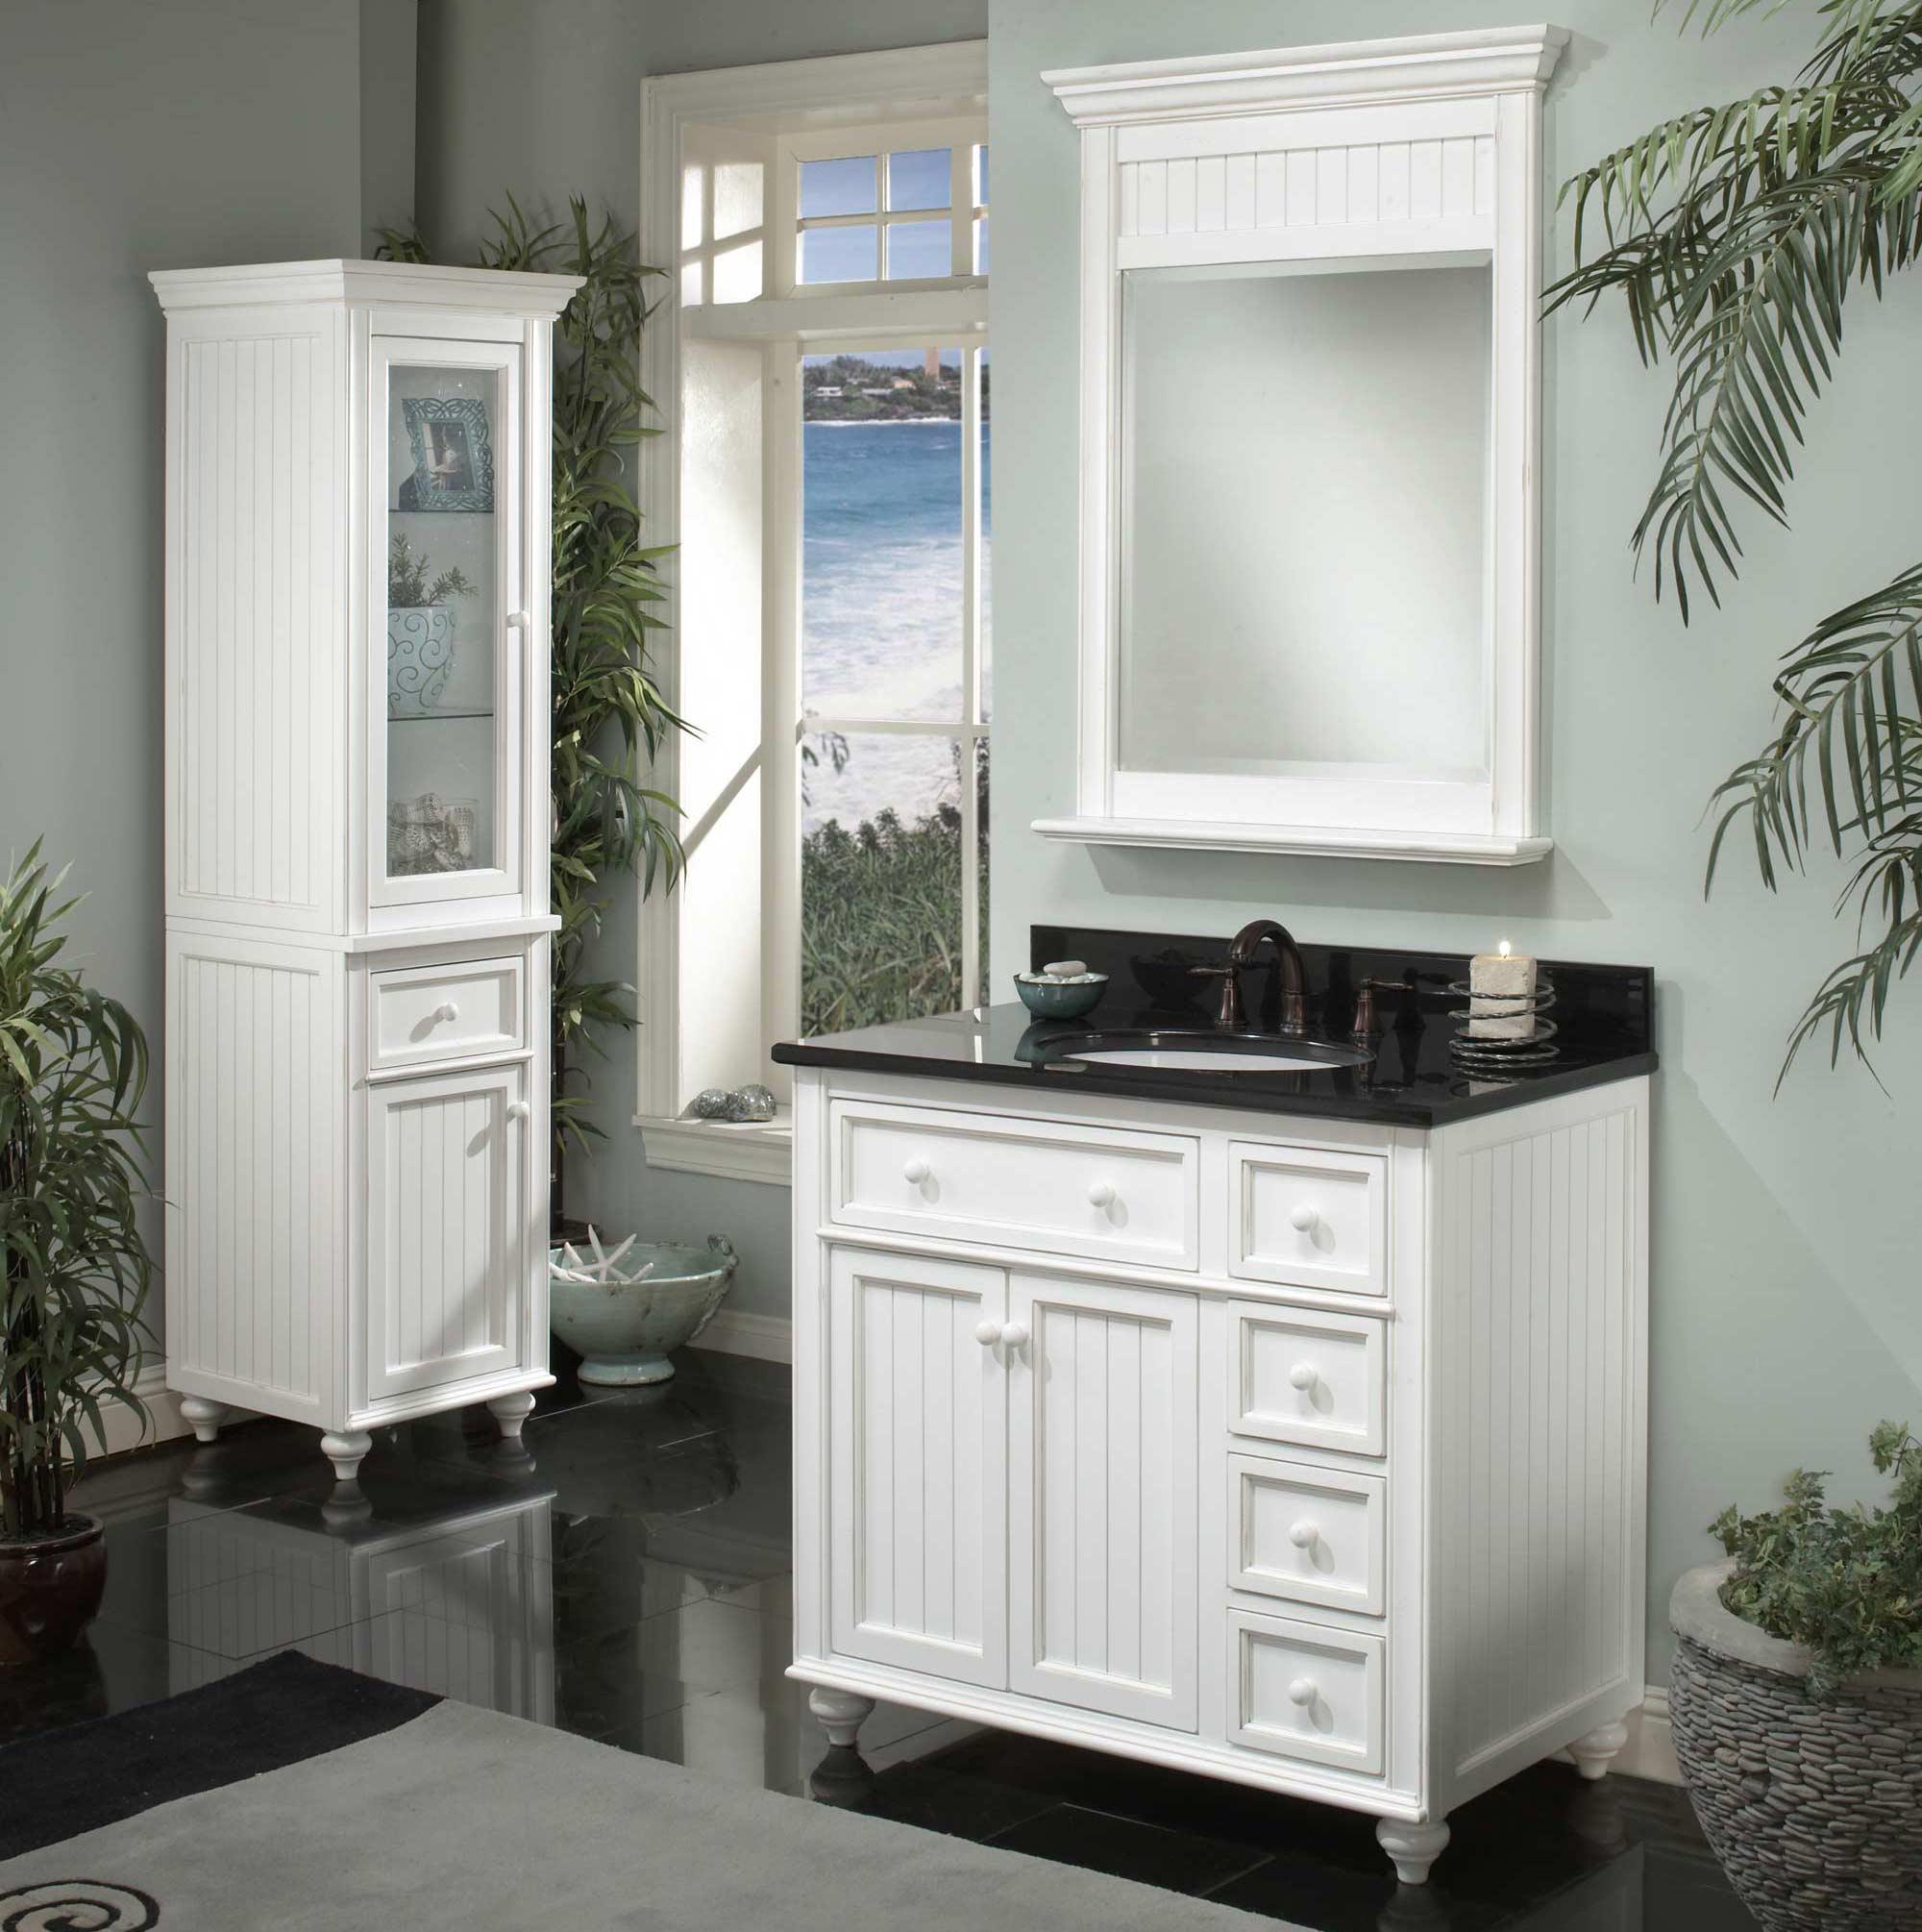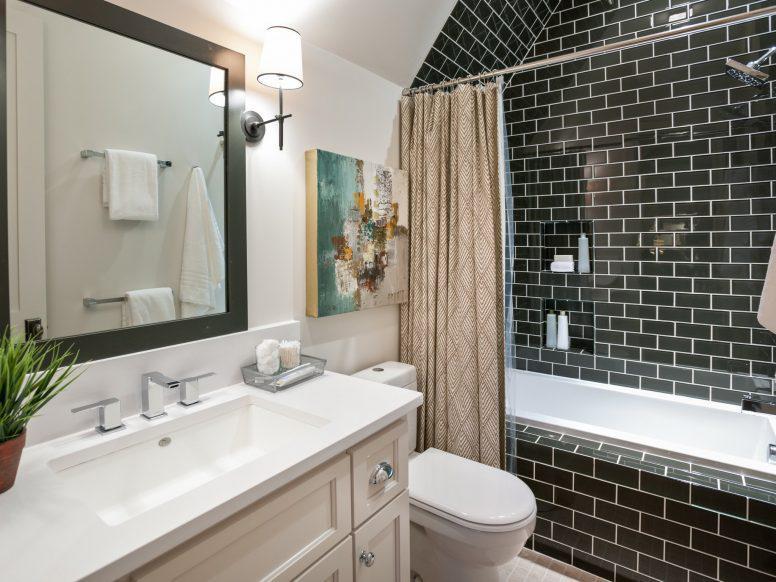The first image is the image on the left, the second image is the image on the right. Analyze the images presented: Is the assertion "The bathroom on the right has a black-and-white diamond pattern floor and a long brown sink vanity." valid? Answer yes or no. No. 